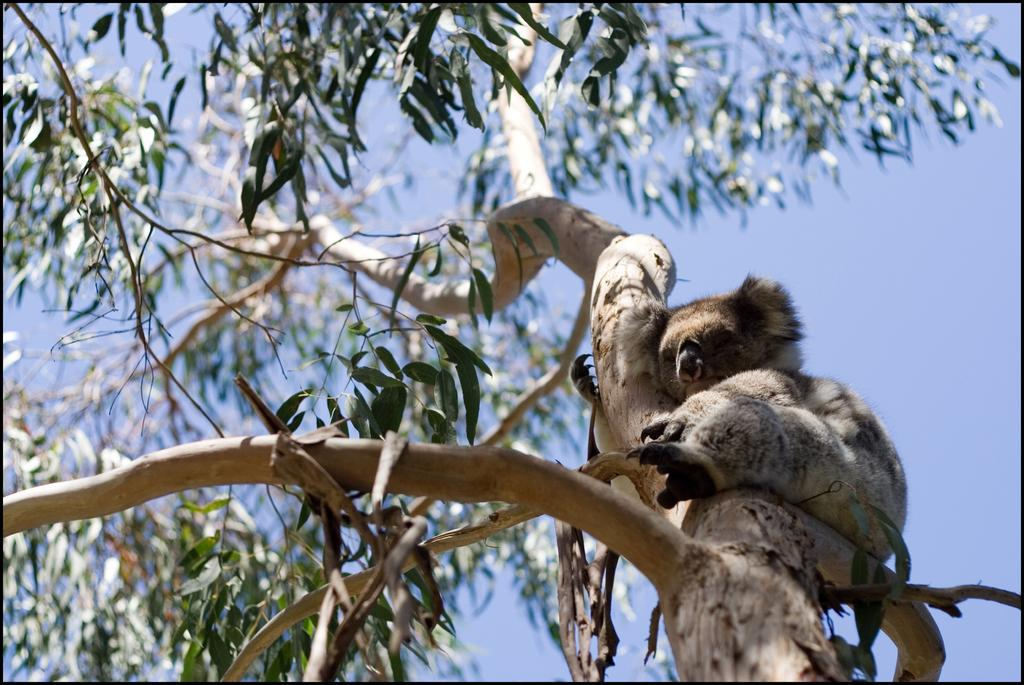What animal is the main subject of the image? There is a koala bear in the image. Where is the koala bear located? The koala bear is on a tree. What can be seen in the background of the image? There is a sky visible in the background of the image. How many goats are visible in the image? There are no goats present in the image; it features a koala bear on a tree. What type of noise does the number in the image make? There is no number present in the image, so it cannot make any noise. 